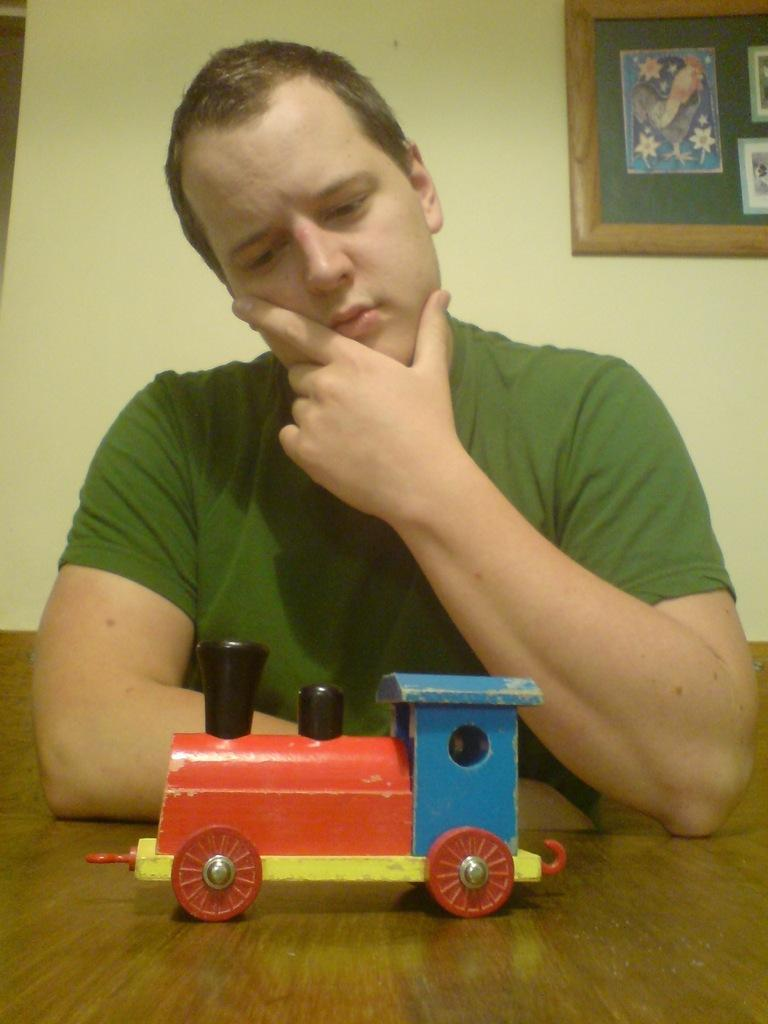What is the man in the image doing? The man is sitting in the image. What object can be seen on the table in the image? There is a toy train on the table. What is visible on the wall in the background of the image? There is a board on the wall in the background. What can be seen on the board? There are posts on the board. What type of error can be seen on the man's shirt in the image? There is no error visible on the man's shirt in the image. 